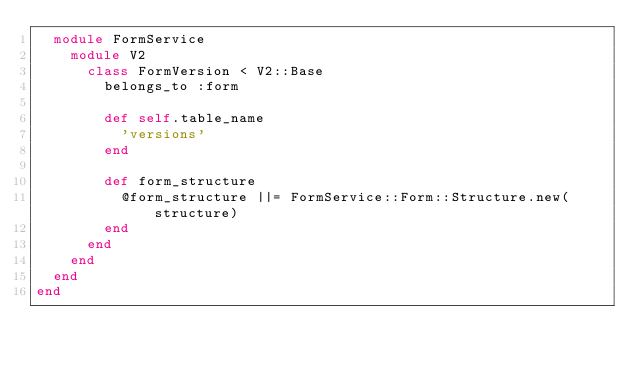<code> <loc_0><loc_0><loc_500><loc_500><_Ruby_>  module FormService
    module V2
      class FormVersion < V2::Base
        belongs_to :form

        def self.table_name
          'versions'
        end

        def form_structure
          @form_structure ||= FormService::Form::Structure.new(structure)
        end
      end
    end
  end
end
</code> 